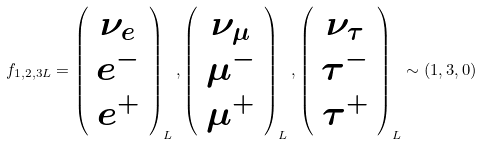<formula> <loc_0><loc_0><loc_500><loc_500>f _ { 1 , 2 , 3 L } = \left ( \begin{array} { c } \nu _ { e } \\ e ^ { - } \\ e ^ { + } \end{array} \right ) _ { L } , \left ( \begin{array} { c } \nu _ { \mu } \\ \mu ^ { - } \\ \mu ^ { + } \end{array} \right ) _ { L } , \left ( \begin{array} { c } \nu _ { \tau } \\ \tau ^ { - } \\ \tau ^ { + } \end{array} \right ) _ { L } \sim ( 1 , 3 , 0 )</formula> 